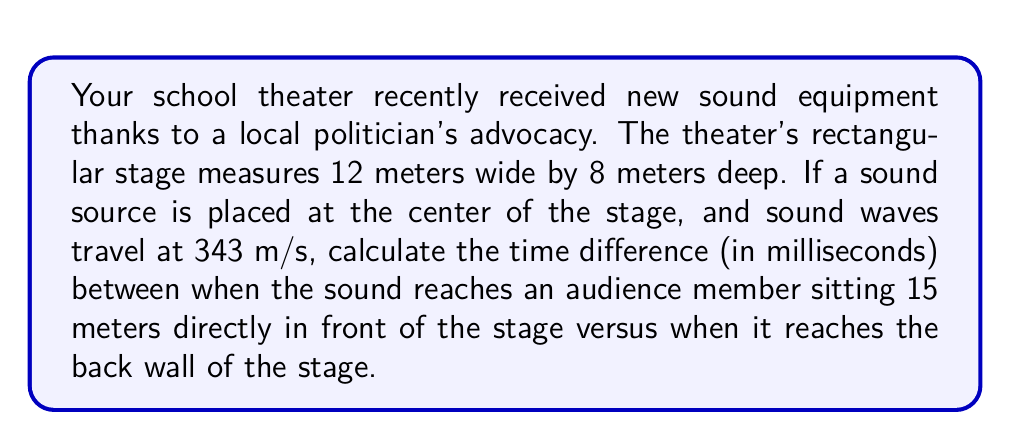Show me your answer to this math problem. Let's approach this step-by-step:

1) First, we need to determine the distances the sound travels in each case.

   a) To the audience member:
      The sound travels straight from the center of the stage to the audience member.
      Distance = 15 meters (given in the question)

   b) To the back wall:
      The stage is 8 meters deep, and the sound source is at the center.
      Distance = 8 / 2 = 4 meters

2) Now, we can calculate the time it takes for the sound to reach each point using the formula:
   $$ t = \frac{d}{v} $$
   where $t$ is time, $d$ is distance, and $v$ is velocity (speed of sound = 343 m/s)

   a) Time to reach the audience member:
      $$ t_1 = \frac{15}{343} \approx 0.0437 \text{ seconds} $$

   b) Time to reach the back wall:
      $$ t_2 = \frac{4}{343} \approx 0.0117 \text{ seconds} $$

3) The time difference is:
   $$ \Delta t = t_1 - t_2 = 0.0437 - 0.0117 = 0.0320 \text{ seconds} $$

4) Convert to milliseconds:
   $$ 0.0320 \text{ seconds} \times 1000 = 32.0 \text{ milliseconds} $$
Answer: 32.0 ms 